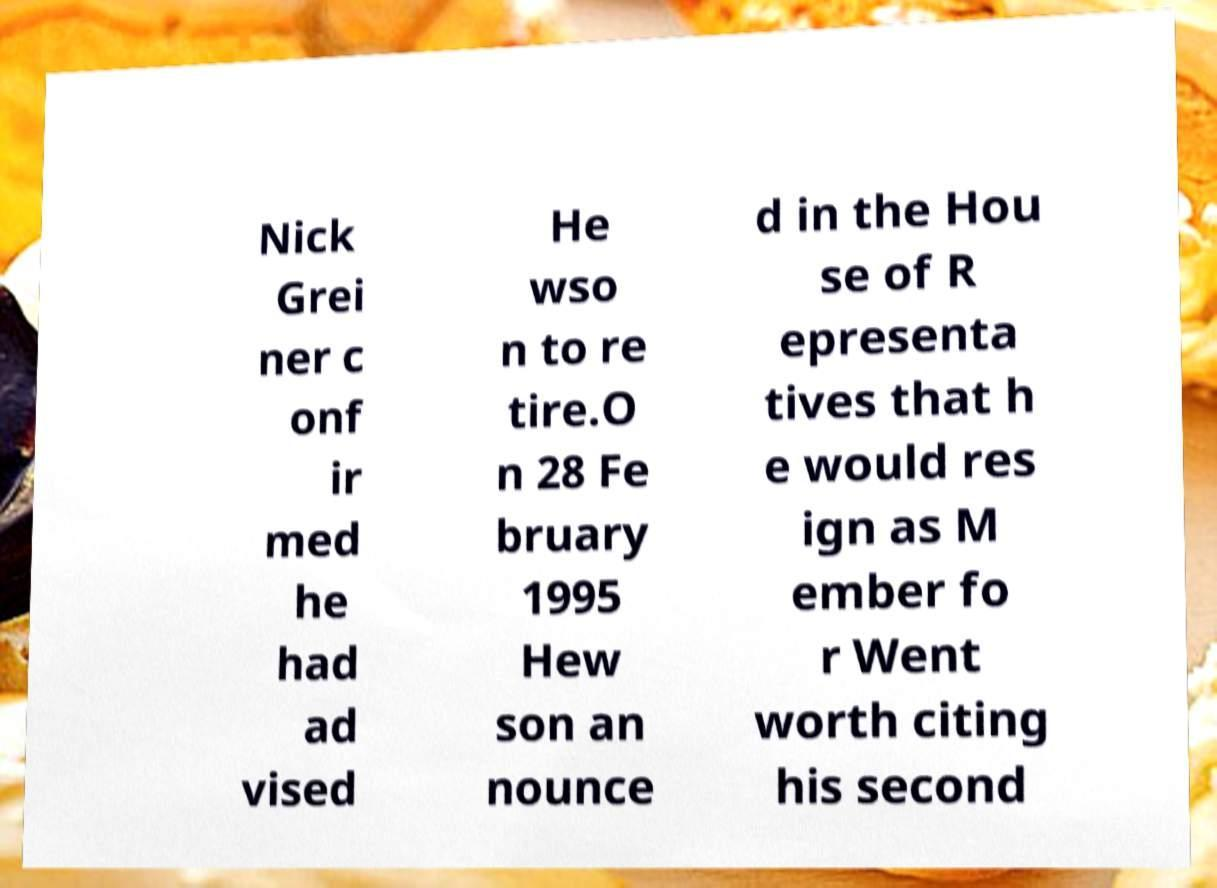Can you accurately transcribe the text from the provided image for me? Nick Grei ner c onf ir med he had ad vised He wso n to re tire.O n 28 Fe bruary 1995 Hew son an nounce d in the Hou se of R epresenta tives that h e would res ign as M ember fo r Went worth citing his second 